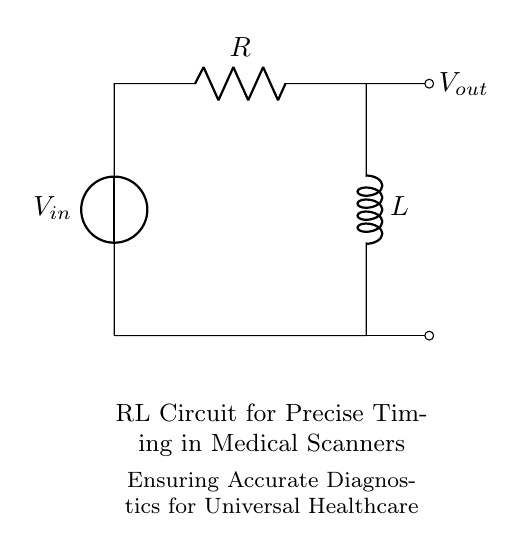What are the components in this circuit? The circuit consists of a voltage source, a resistor, and an inductor. Each component can be identified by their respective symbols and labels in the diagram.
Answer: Voltage source, resistor, inductor What is the output voltage in the circuit? The output voltage is indicated by the label next to the output terminal, which shows it as V out. Therefore, the output voltage is defined by the circuit's operation and conditions.
Answer: V out How does the resistor affect the timing of the circuit? The resistor introduces resistance that impacts the charging and discharging time of the inductor, influencing the overall timing characteristics of the circuit. The resistor limits the current flowing through the circuit, which affects the time constant.
Answer: It increases timing What is the primary function of the inductor in this RL circuit? The inductor stores energy in a magnetic field when current passes through. In this circuit, the inductor works with the resistor to create a delay effect, which can be used for timing in medical scanners.
Answer: Energy storage What is the role of this RL circuit in medical imaging? The RL circuit is used for precise timing control in medical scanners, allowing for accurate diagnostics and imaging processes essential for universal healthcare. The timing aspects are critical for obtaining clear imaging results.
Answer: Precise timing control What would happen if we increased the resistance in the circuit? Increasing the resistance would result in a longer time constant and slower response time of the circuit, leading to an increase in the delay for current to build up in the circuit, which may affect timing in medical applications.
Answer: Longer delay 